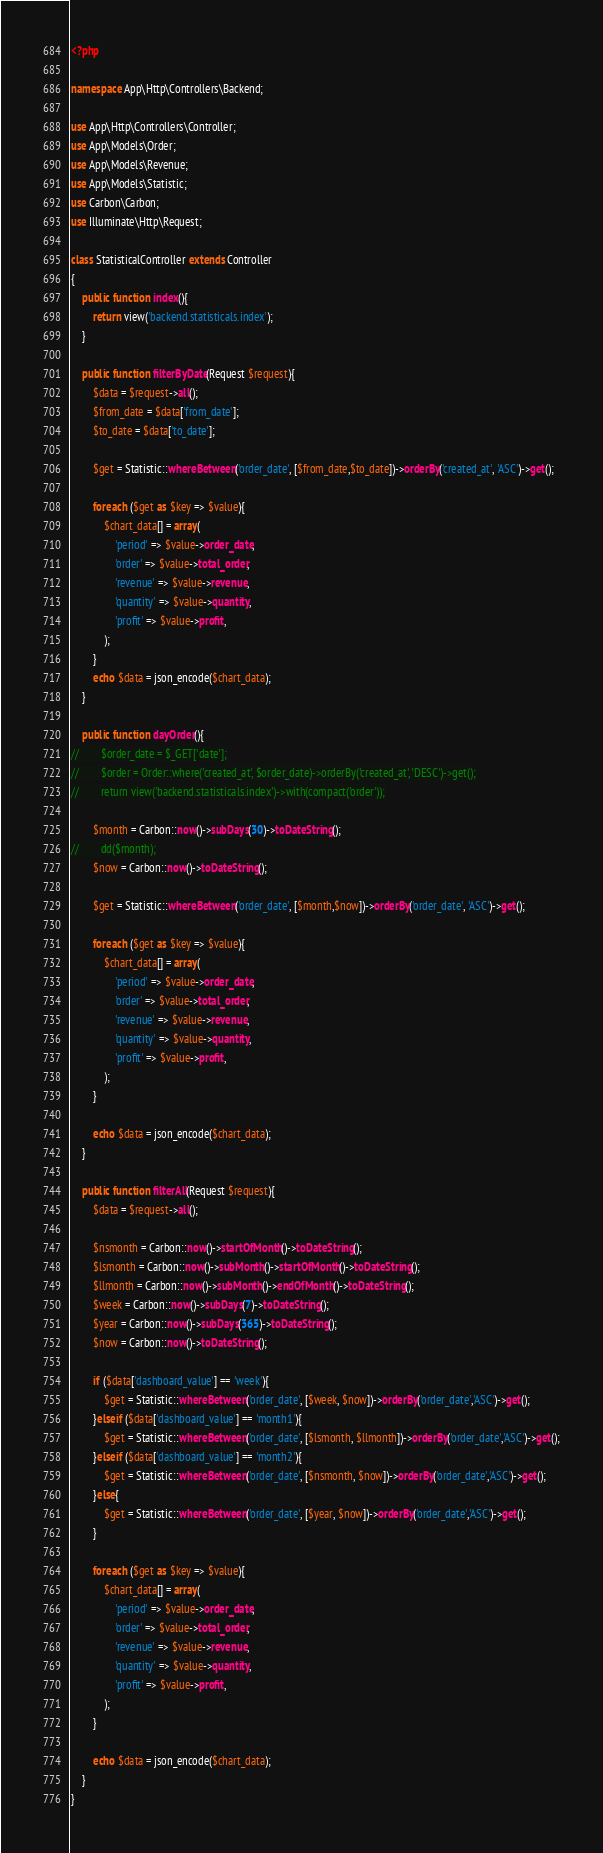<code> <loc_0><loc_0><loc_500><loc_500><_PHP_><?php

namespace App\Http\Controllers\Backend;

use App\Http\Controllers\Controller;
use App\Models\Order;
use App\Models\Revenue;
use App\Models\Statistic;
use Carbon\Carbon;
use Illuminate\Http\Request;

class StatisticalController extends Controller
{
    public function index(){
        return view('backend.statisticals.index');
    }

    public function filterByDate(Request $request){
        $data = $request->all();
        $from_date = $data['from_date'];
        $to_date = $data['to_date'];

        $get = Statistic::whereBetween('order_date', [$from_date,$to_date])->orderBy('created_at', 'ASC')->get();

        foreach ($get as $key => $value){
            $chart_data[] = array(
                'period' => $value->order_date,
                'order' => $value->total_order,
                'revenue' => $value->revenue,
                'quantity' => $value->quantity,
                'profit' => $value->profit,
            );
        }
        echo $data = json_encode($chart_data);
    }

    public function dayOrder(){
//        $order_date = $_GET['date'];
//        $order = Order::where('created_at', $order_date)->orderBy('created_at', 'DESC')->get();
//        return view('backend.statisticals.index')->with(compact('order'));

        $month = Carbon::now()->subDays(30)->toDateString();
//        dd($month);
        $now = Carbon::now()->toDateString();

        $get = Statistic::whereBetween('order_date', [$month,$now])->orderBy('order_date', 'ASC')->get();

        foreach ($get as $key => $value){
            $chart_data[] = array(
                'period' => $value->order_date,
                'order' => $value->total_order,
                'revenue' => $value->revenue,
                'quantity' => $value->quantity,
                'profit' => $value->profit,
            );
        }

        echo $data = json_encode($chart_data);
    }

    public function filterAll(Request $request){
        $data = $request->all();

        $nsmonth = Carbon::now()->startOfMonth()->toDateString();
        $lsmonth = Carbon::now()->subMonth()->startOfMonth()->toDateString();
        $llmonth = Carbon::now()->subMonth()->endOfMonth()->toDateString();
        $week = Carbon::now()->subDays(7)->toDateString();
        $year = Carbon::now()->subDays(365)->toDateString();
        $now = Carbon::now()->toDateString();

        if ($data['dashboard_value'] == 'week'){
            $get = Statistic::whereBetween('order_date', [$week, $now])->orderBy('order_date','ASC')->get();
        }elseif ($data['dashboard_value'] == 'month1'){
            $get = Statistic::whereBetween('order_date', [$lsmonth, $llmonth])->orderBy('order_date','ASC')->get();
        }elseif ($data['dashboard_value'] == 'month2'){
            $get = Statistic::whereBetween('order_date', [$nsmonth, $now])->orderBy('order_date','ASC')->get();
        }else{
            $get = Statistic::whereBetween('order_date', [$year, $now])->orderBy('order_date','ASC')->get();
        }

        foreach ($get as $key => $value){
            $chart_data[] = array(
                'period' => $value->order_date,
                'order' => $value->total_order,
                'revenue' => $value->revenue,
                'quantity' => $value->quantity,
                'profit' => $value->profit,
            );
        }

        echo $data = json_encode($chart_data);
    }
}
</code> 